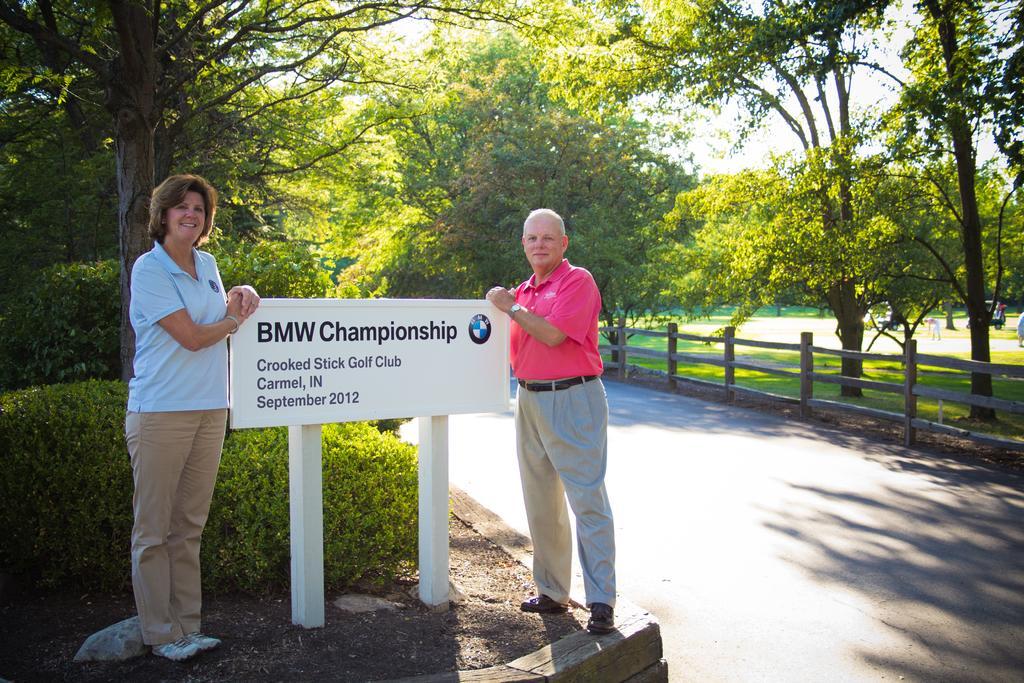Describe this image in one or two sentences. In this image, we can see a road in between trees. There is a fencing on the right side of the image. There are some plants on the left side of the image. There is a board in between two persons. 